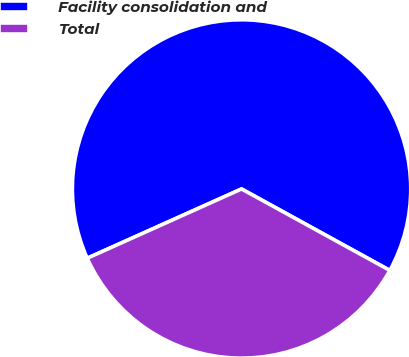<chart> <loc_0><loc_0><loc_500><loc_500><pie_chart><fcel>Facility consolidation and<fcel>Total<nl><fcel>64.71%<fcel>35.29%<nl></chart> 